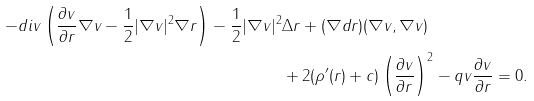<formula> <loc_0><loc_0><loc_500><loc_500>- d i v \left ( \frac { \partial v } { \partial r } \nabla v - \frac { 1 } { 2 } | \nabla v | ^ { 2 } \nabla r \right ) - \frac { 1 } { 2 } | \nabla v | ^ { 2 } & \Delta r + ( \nabla d r ) ( \nabla v , \nabla v ) \\ & + 2 ( \rho ^ { \prime } ( r ) + c ) \left ( \frac { \partial v } { \partial r } \right ) ^ { 2 } - q v \frac { \partial v } { \partial r } = 0 .</formula> 